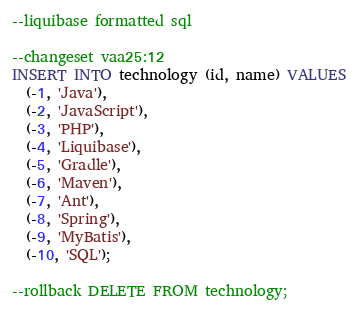<code> <loc_0><loc_0><loc_500><loc_500><_SQL_>--liquibase formatted sql

--changeset vaa25:12
INSERT INTO technology (id, name) VALUES
  (-1, 'Java'),
  (-2, 'JavaScript'),
  (-3, 'PHP'),
  (-4, 'Liquibase'),
  (-5, 'Gradle'),
  (-6, 'Maven'),
  (-7, 'Ant'),
  (-8, 'Spring'),
  (-9, 'MyBatis'),
  (-10, 'SQL');

--rollback DELETE FROM technology;
</code> 